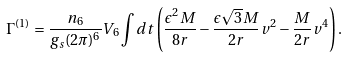Convert formula to latex. <formula><loc_0><loc_0><loc_500><loc_500>\Gamma ^ { ( 1 ) } = \frac { n _ { 6 } } { g _ { s } ( 2 \pi ) ^ { 6 } } V _ { 6 } \int d t \left ( \frac { \epsilon ^ { 2 } M } { 8 r } - \frac { \epsilon \sqrt { 3 } M } { 2 r } v ^ { 2 } - \frac { M } { 2 r } v ^ { 4 } \right ) .</formula> 